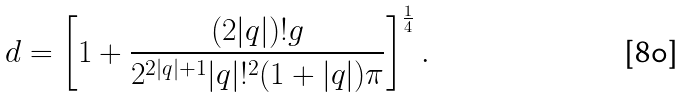<formula> <loc_0><loc_0><loc_500><loc_500>d = \left [ 1 + \frac { ( 2 | q | ) ! g } { 2 ^ { 2 | q | + 1 } | q | ! ^ { 2 } ( 1 + | q | ) \pi } \right ] ^ { \frac { 1 } { 4 } } .</formula> 